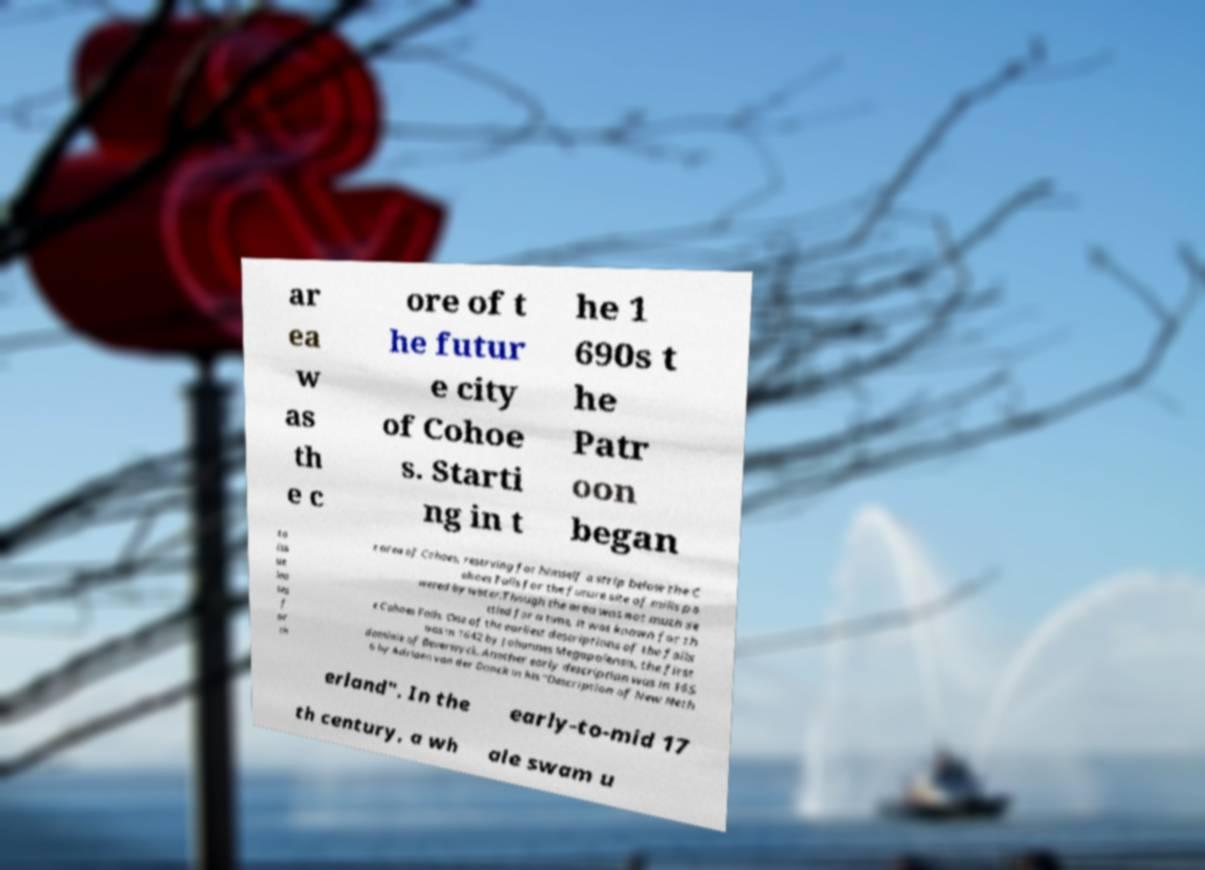Please identify and transcribe the text found in this image. ar ea w as th e c ore of t he futur e city of Cohoe s. Starti ng in t he 1 690s t he Patr oon began to iss ue lea ses f or th e area of Cohoes, reserving for himself a strip below the C ohoes Falls for the future site of mills po wered by water.Though the area was not much se ttled for a time, it was known for th e Cohoes Falls. One of the earliest descriptions of the falls was in 1642 by Johannes Megapolensis, the first dominie of Beverwyck. Another early description was in 165 6 by Adriaen van der Donck in his "Description of New Neth erland". In the early-to-mid 17 th century, a wh ale swam u 